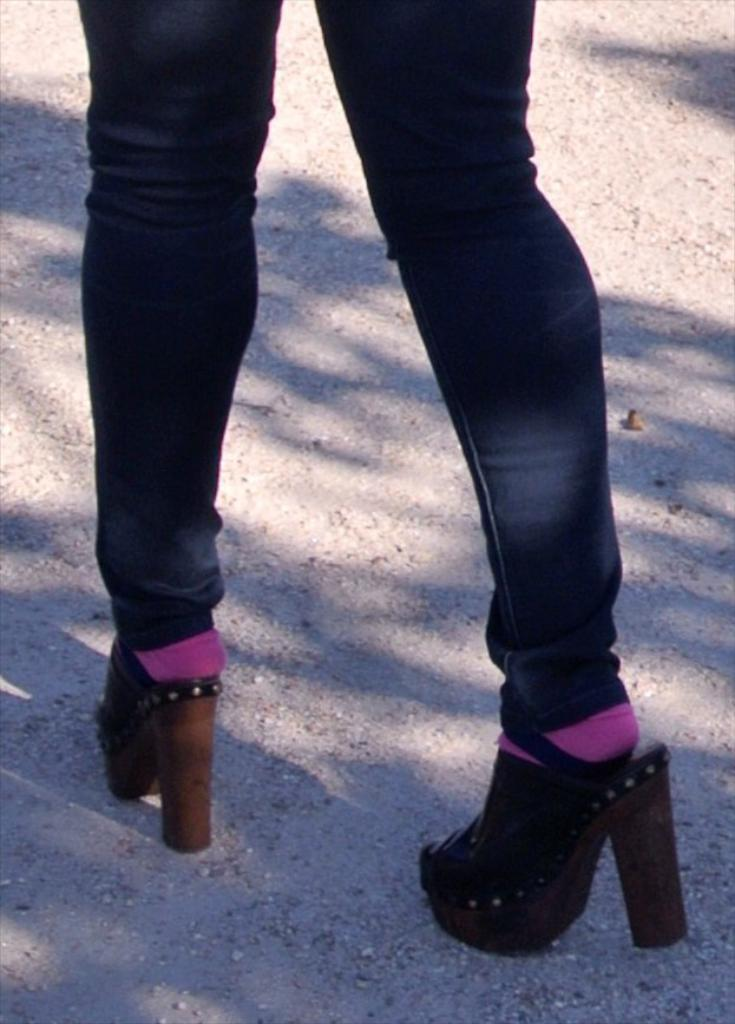Who is the main subject in the image? There is a woman in the image. What is the woman doing in the image? The woman is walking. What type of pants is the woman wearing? The woman is wearing black pants. What color are the socks the woman is wearing? The woman is wearing purple socks. What type of footwear is the woman wearing? The woman is wearing high sandals. What type of surface is visible in the image? There is soil visible on the floor in the image. Can you see a volleyball being played in the image? There is no volleyball or any indication of a game being played in the image. What type of rose is the woman holding in the image? There is no rose present in the image; the woman is simply walking. 